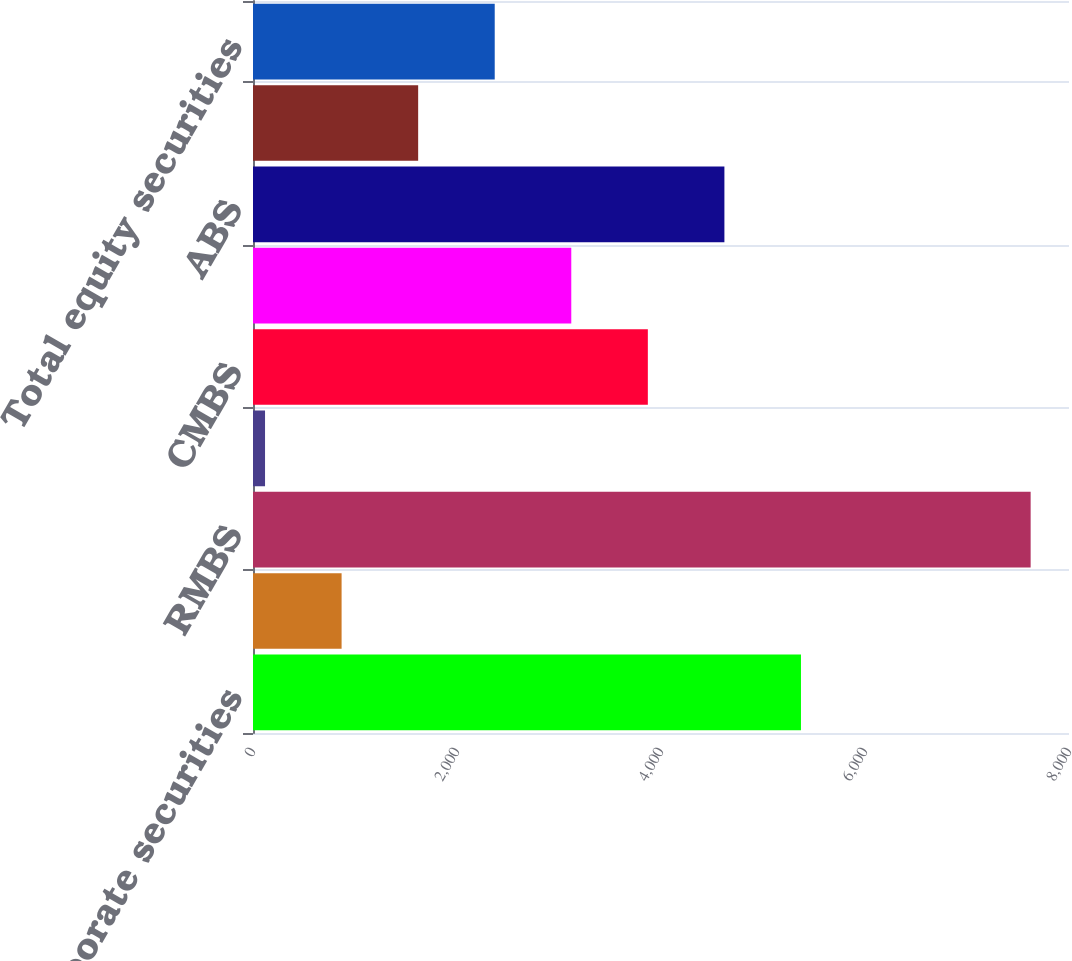Convert chart to OTSL. <chart><loc_0><loc_0><loc_500><loc_500><bar_chart><fcel>Foreign corporate securities<fcel>Foreign government securities<fcel>RMBS<fcel>US Treasury and agency<fcel>CMBS<fcel>State and political<fcel>ABS<fcel>Non-redeemable preferred stock<fcel>Total equity securities<nl><fcel>5372.2<fcel>868.6<fcel>7624<fcel>118<fcel>3871<fcel>3120.4<fcel>4621.6<fcel>1619.2<fcel>2369.8<nl></chart> 